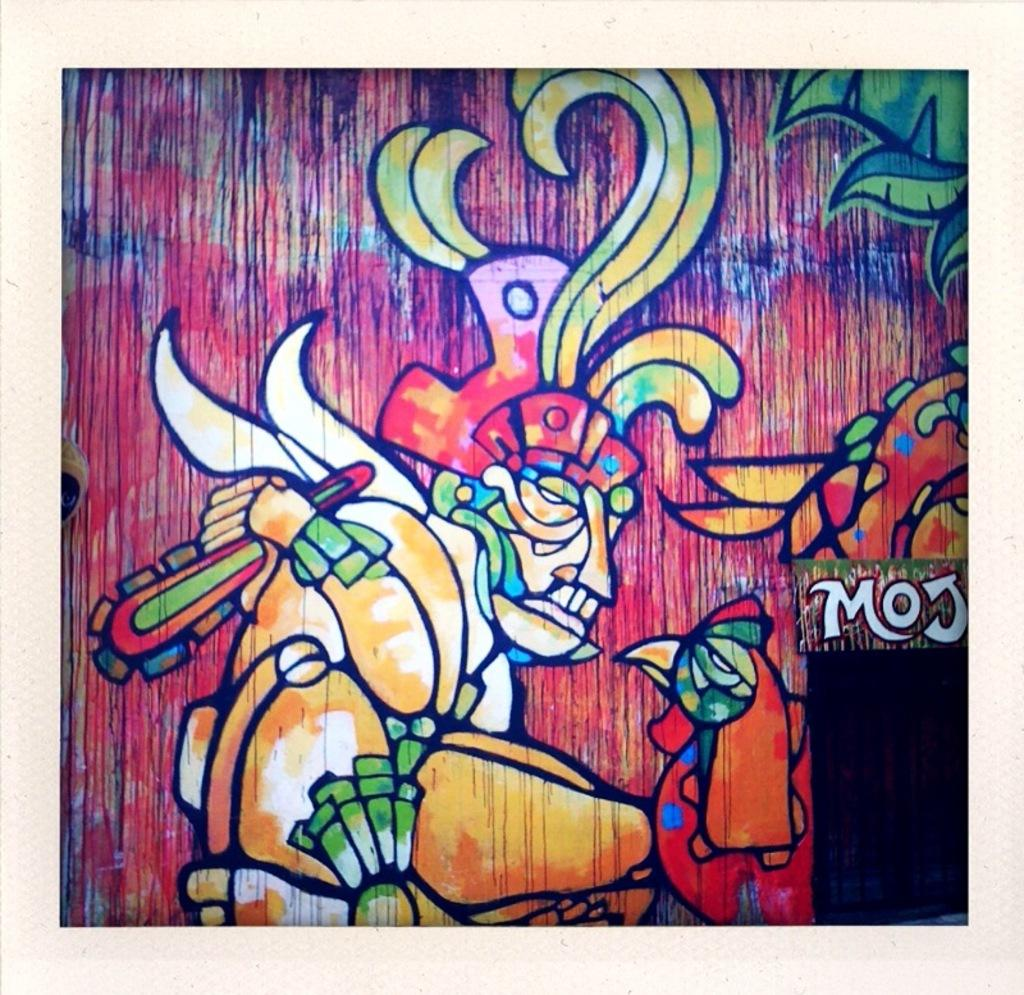<image>
Summarize the visual content of the image. Painting of a man looking at a chicken and the word "MOJ" next to them. 